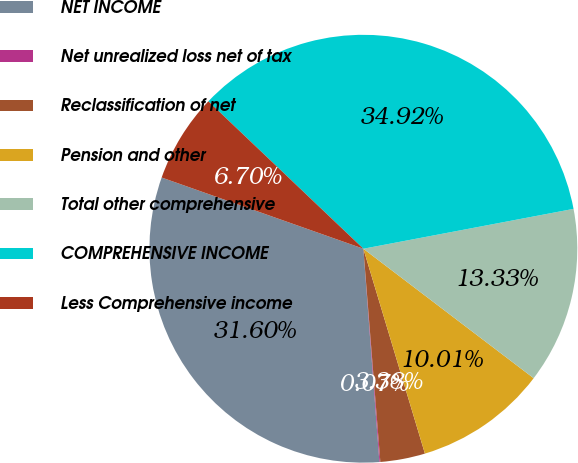Convert chart. <chart><loc_0><loc_0><loc_500><loc_500><pie_chart><fcel>NET INCOME<fcel>Net unrealized loss net of tax<fcel>Reclassification of net<fcel>Pension and other<fcel>Total other comprehensive<fcel>COMPREHENSIVE INCOME<fcel>Less Comprehensive income<nl><fcel>31.6%<fcel>0.07%<fcel>3.38%<fcel>10.01%<fcel>13.33%<fcel>34.92%<fcel>6.7%<nl></chart> 